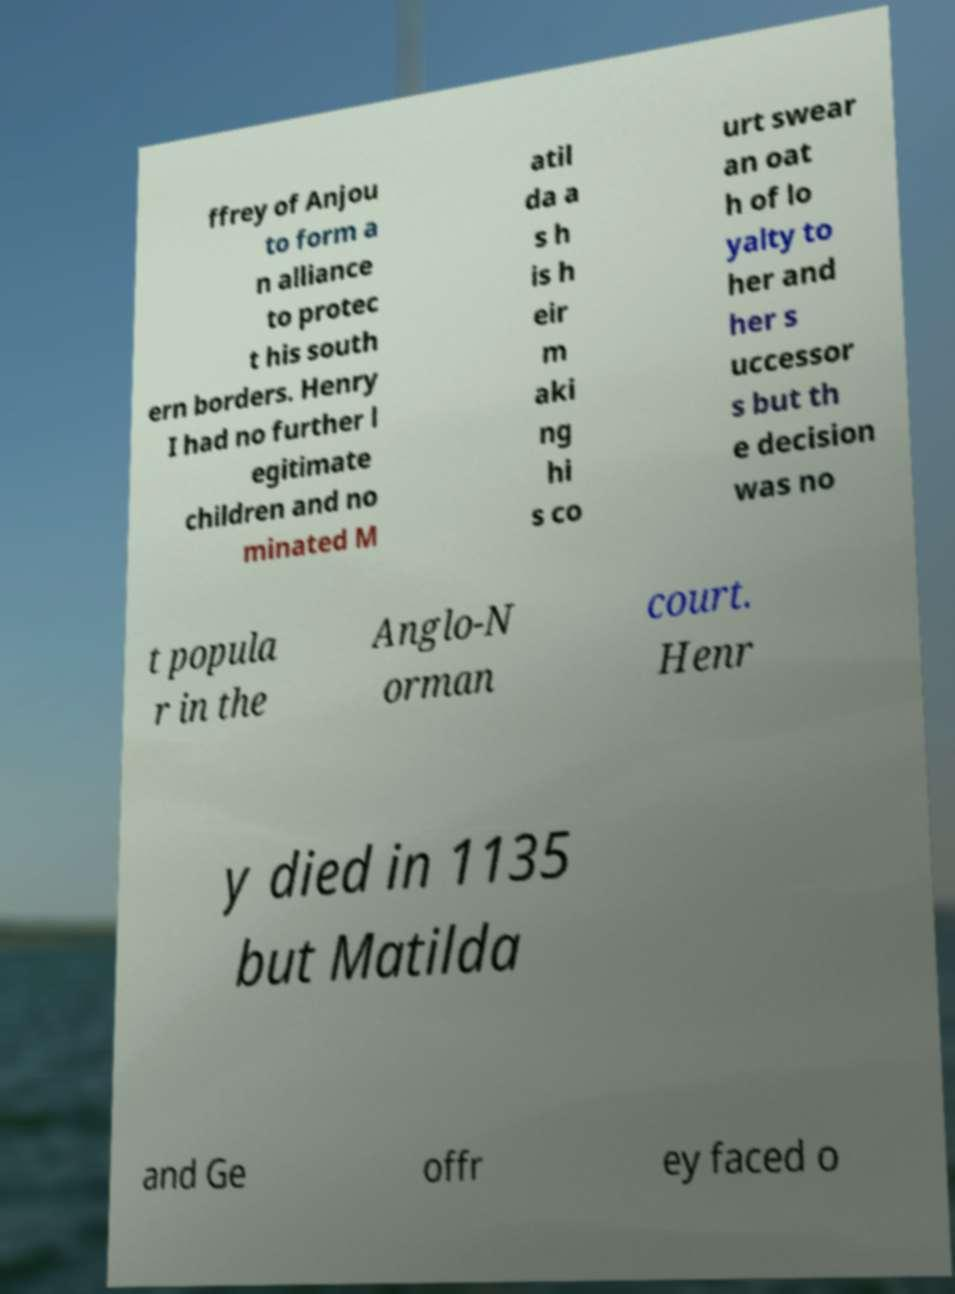I need the written content from this picture converted into text. Can you do that? ffrey of Anjou to form a n alliance to protec t his south ern borders. Henry I had no further l egitimate children and no minated M atil da a s h is h eir m aki ng hi s co urt swear an oat h of lo yalty to her and her s uccessor s but th e decision was no t popula r in the Anglo-N orman court. Henr y died in 1135 but Matilda and Ge offr ey faced o 